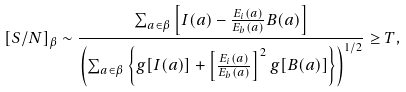<formula> <loc_0><loc_0><loc_500><loc_500>[ S / N ] _ { \beta } \sim \frac { \sum _ { a \in \beta } { \left [ I ( a ) - \frac { E _ { i } ( a ) } { E _ { b } ( a ) } B ( a ) \right ] } } { \left ( \sum _ { a \in \beta } { \left \{ g [ I ( a ) ] + \left [ \frac { E _ { i } ( a ) } { E _ { b } ( a ) } \right ] ^ { 2 } g [ B ( a ) ] \right \} } \right ) ^ { 1 / 2 } } \geq T ,</formula> 